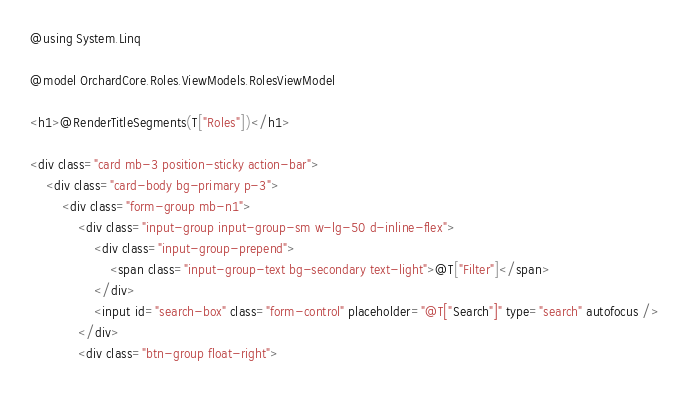<code> <loc_0><loc_0><loc_500><loc_500><_C#_>@using System.Linq

@model OrchardCore.Roles.ViewModels.RolesViewModel

<h1>@RenderTitleSegments(T["Roles"])</h1>

<div class="card mb-3 position-sticky action-bar">
    <div class="card-body bg-primary p-3">
        <div class="form-group mb-n1">
            <div class="input-group input-group-sm w-lg-50 d-inline-flex">
                <div class="input-group-prepend">
                    <span class="input-group-text bg-secondary text-light">@T["Filter"]</span>
                </div>
                <input id="search-box" class="form-control" placeholder="@T["Search"]" type="search" autofocus />
            </div>
            <div class="btn-group float-right"></code> 